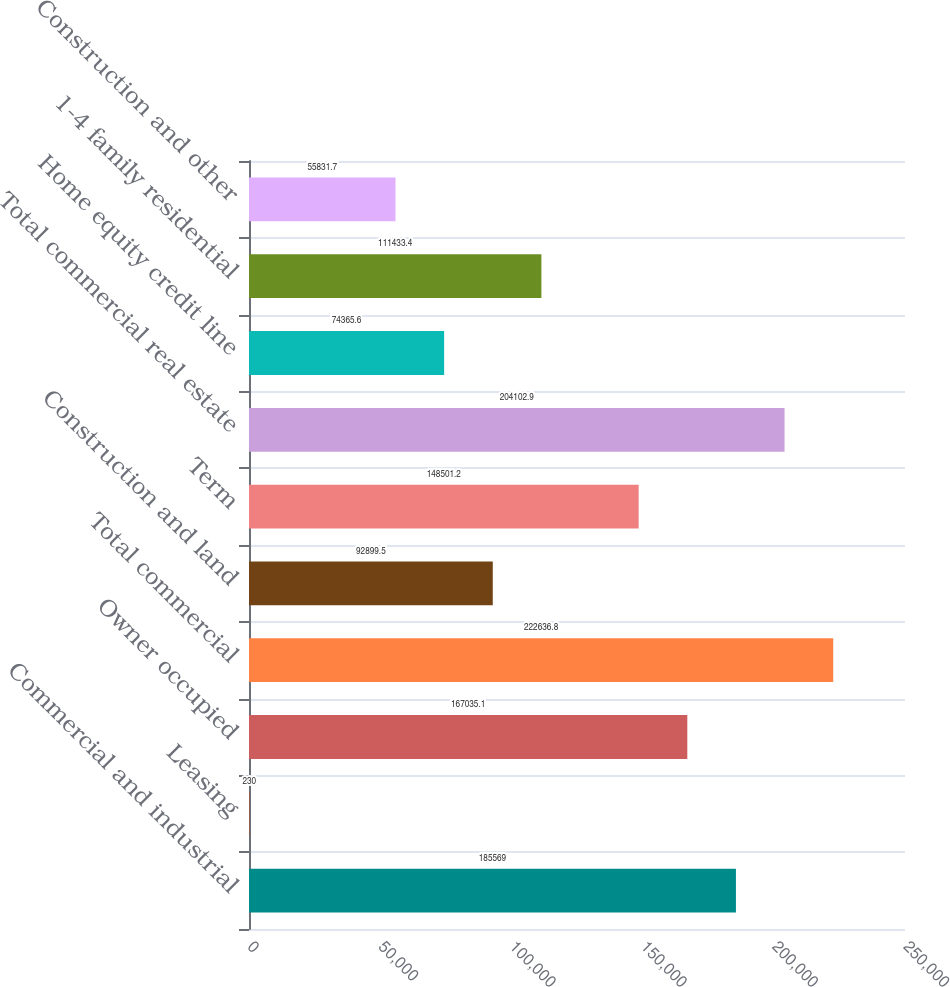Convert chart. <chart><loc_0><loc_0><loc_500><loc_500><bar_chart><fcel>Commercial and industrial<fcel>Leasing<fcel>Owner occupied<fcel>Total commercial<fcel>Construction and land<fcel>Term<fcel>Total commercial real estate<fcel>Home equity credit line<fcel>1-4 family residential<fcel>Construction and other<nl><fcel>185569<fcel>230<fcel>167035<fcel>222637<fcel>92899.5<fcel>148501<fcel>204103<fcel>74365.6<fcel>111433<fcel>55831.7<nl></chart> 